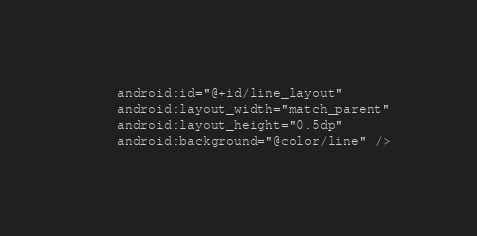Convert code to text. <code><loc_0><loc_0><loc_500><loc_500><_XML_>    android:id="@+id/line_layout"
    android:layout_width="match_parent"
    android:layout_height="0.5dp"
    android:background="@color/line" />
</code> 